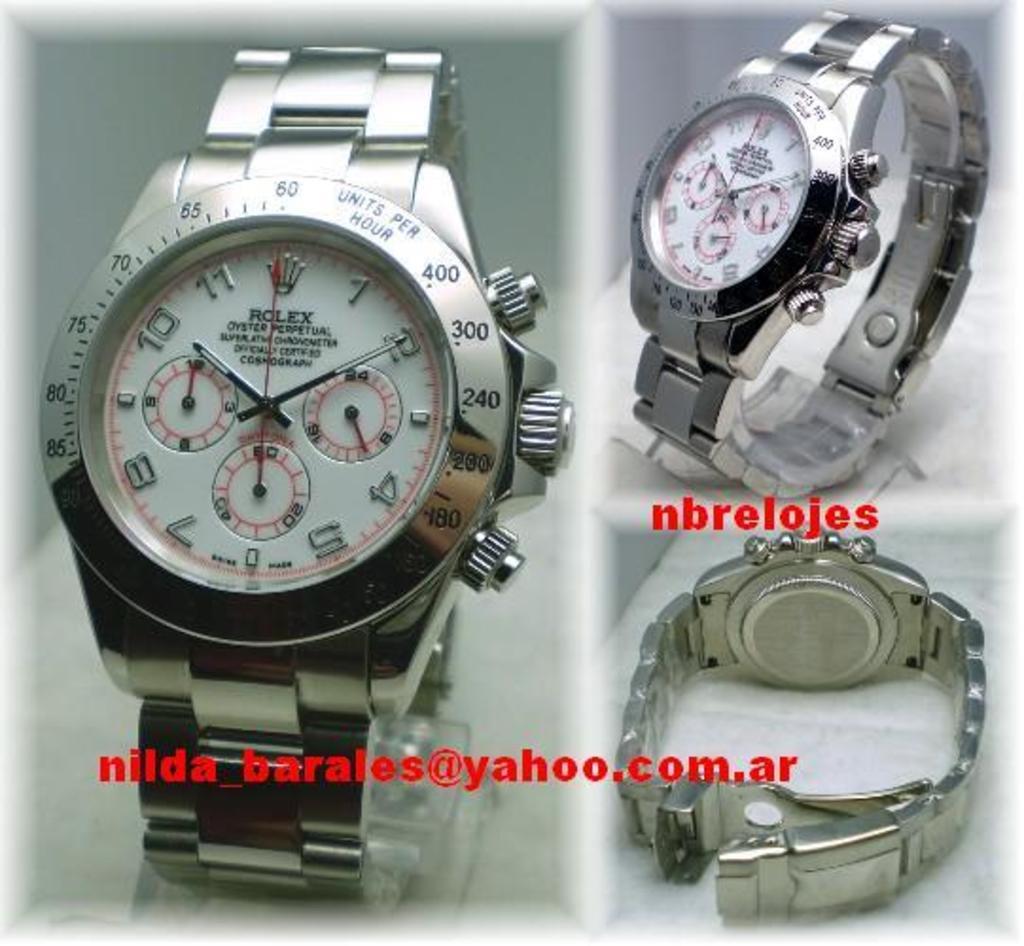What brand of watch are these?
Keep it short and to the point. Rolex. What does the ring around the face of the watch measure?
Provide a short and direct response. Units per hour. 